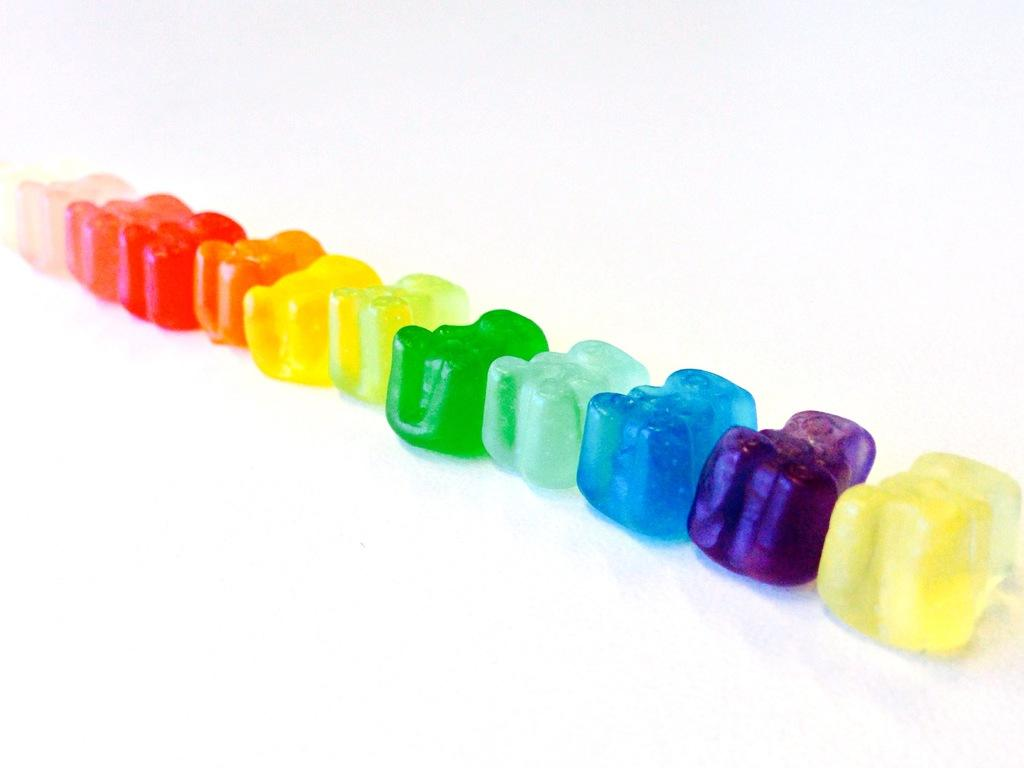What can be observed about the objects in the image in terms of color? There are multi-colored objects in the image. Can you describe the appearance of these objects? Unfortunately, the provided facts do not give enough information to describe the appearance of the objects. Are there any specific shapes or patterns visible on the objects? The provided facts do not give enough information to describe the shapes or patterns on the objects. What year is depicted on the curtain in the image? There is no curtain present in the image, and therefore no year can be observed on it. 